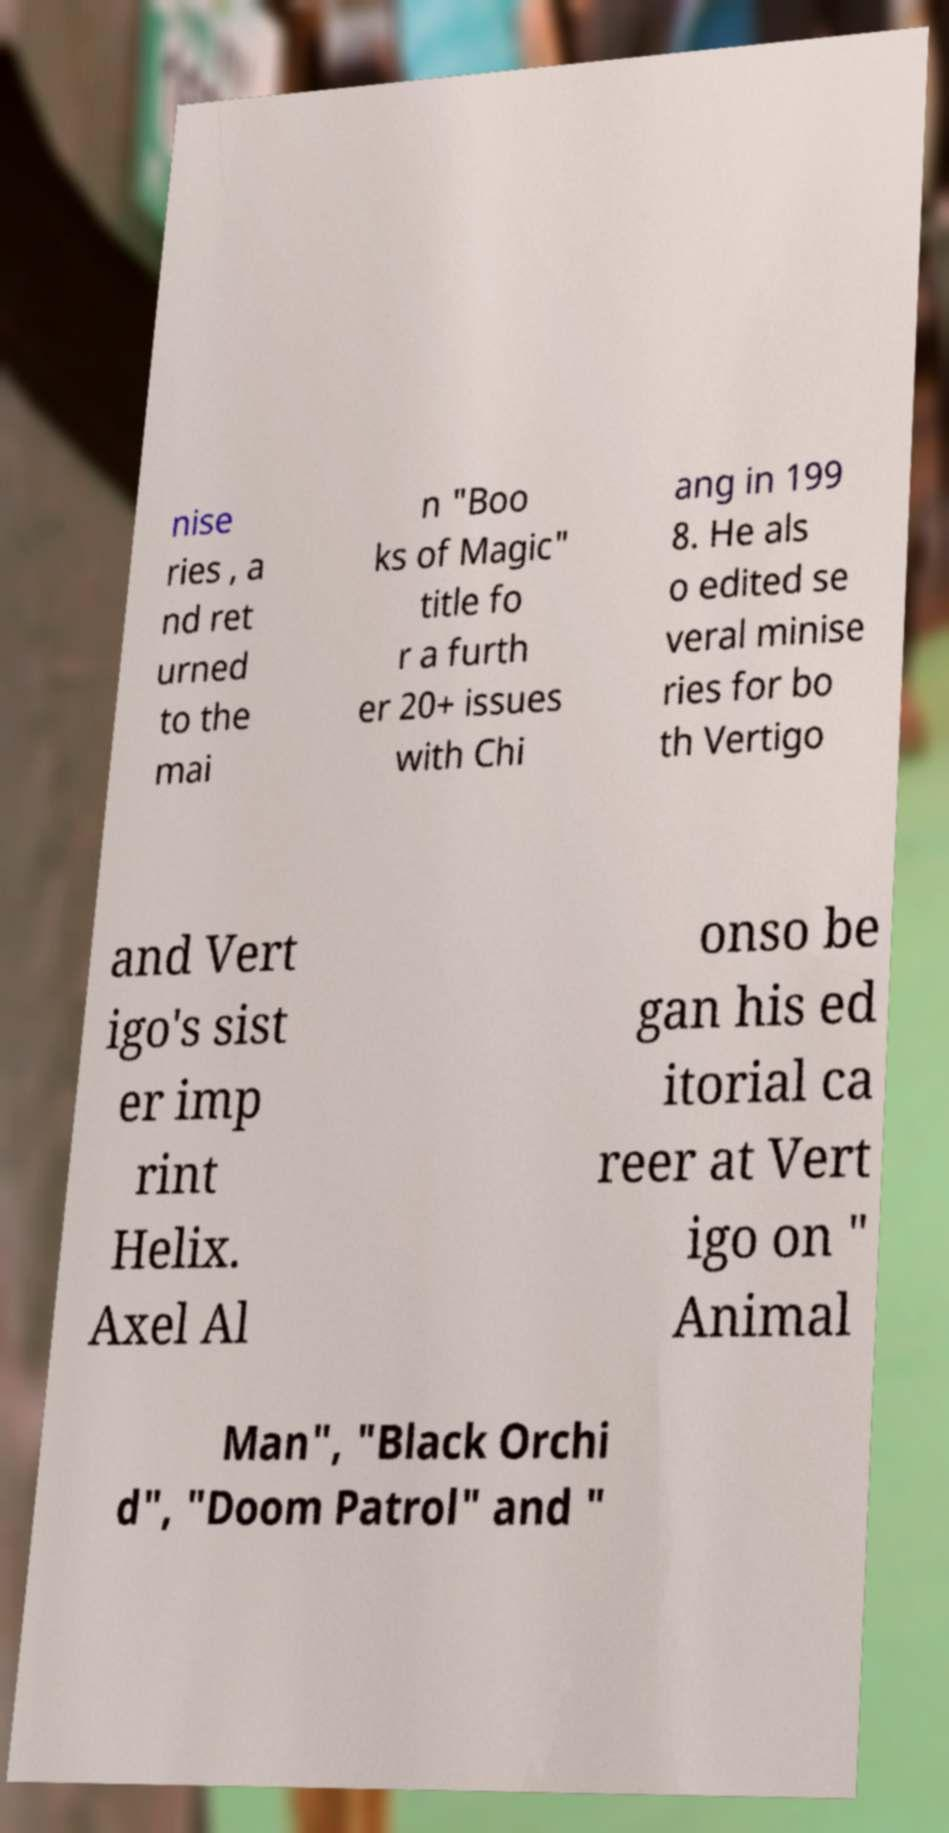Please identify and transcribe the text found in this image. nise ries , a nd ret urned to the mai n "Boo ks of Magic" title fo r a furth er 20+ issues with Chi ang in 199 8. He als o edited se veral minise ries for bo th Vertigo and Vert igo's sist er imp rint Helix. Axel Al onso be gan his ed itorial ca reer at Vert igo on " Animal Man", "Black Orchi d", "Doom Patrol" and " 